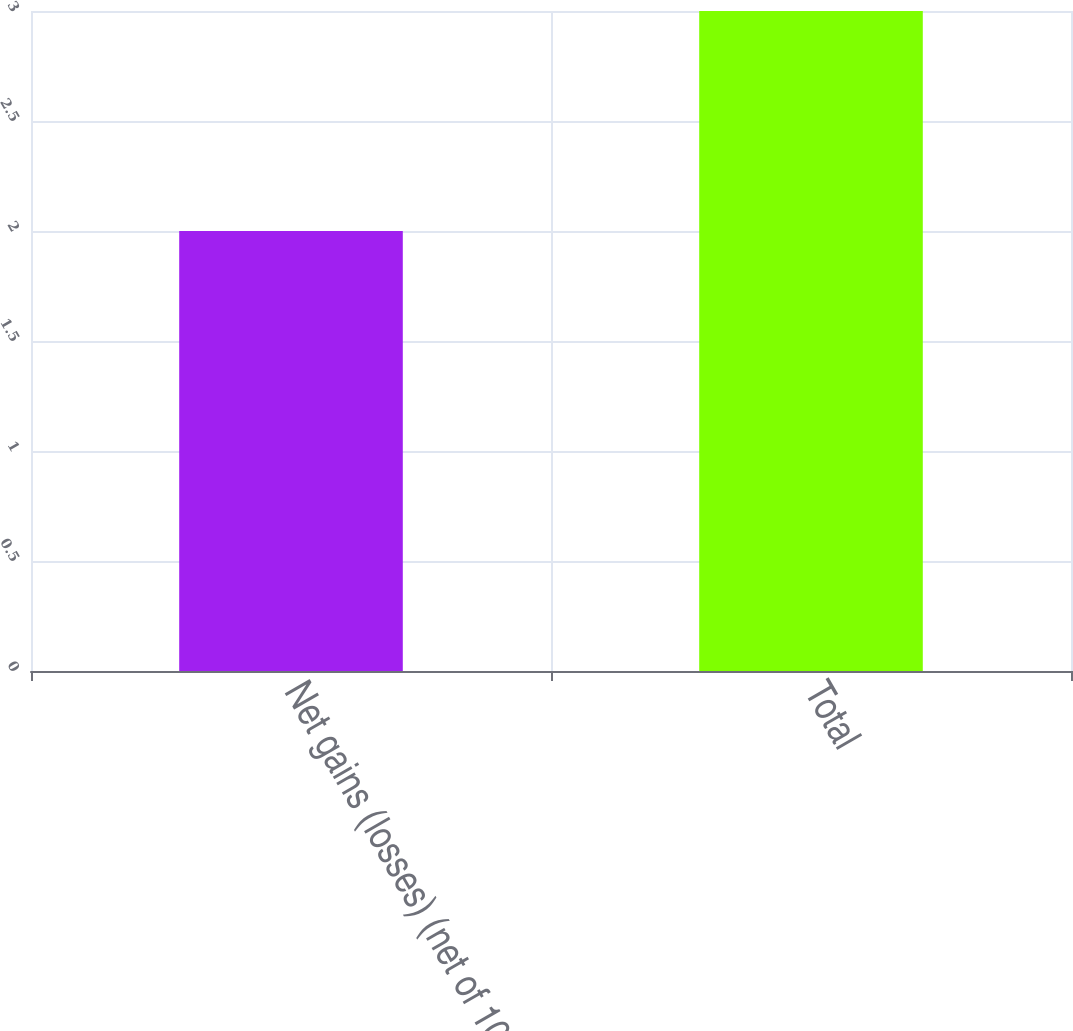Convert chart to OTSL. <chart><loc_0><loc_0><loc_500><loc_500><bar_chart><fcel>Net gains (losses) (net of 102<fcel>Total<nl><fcel>2<fcel>3<nl></chart> 